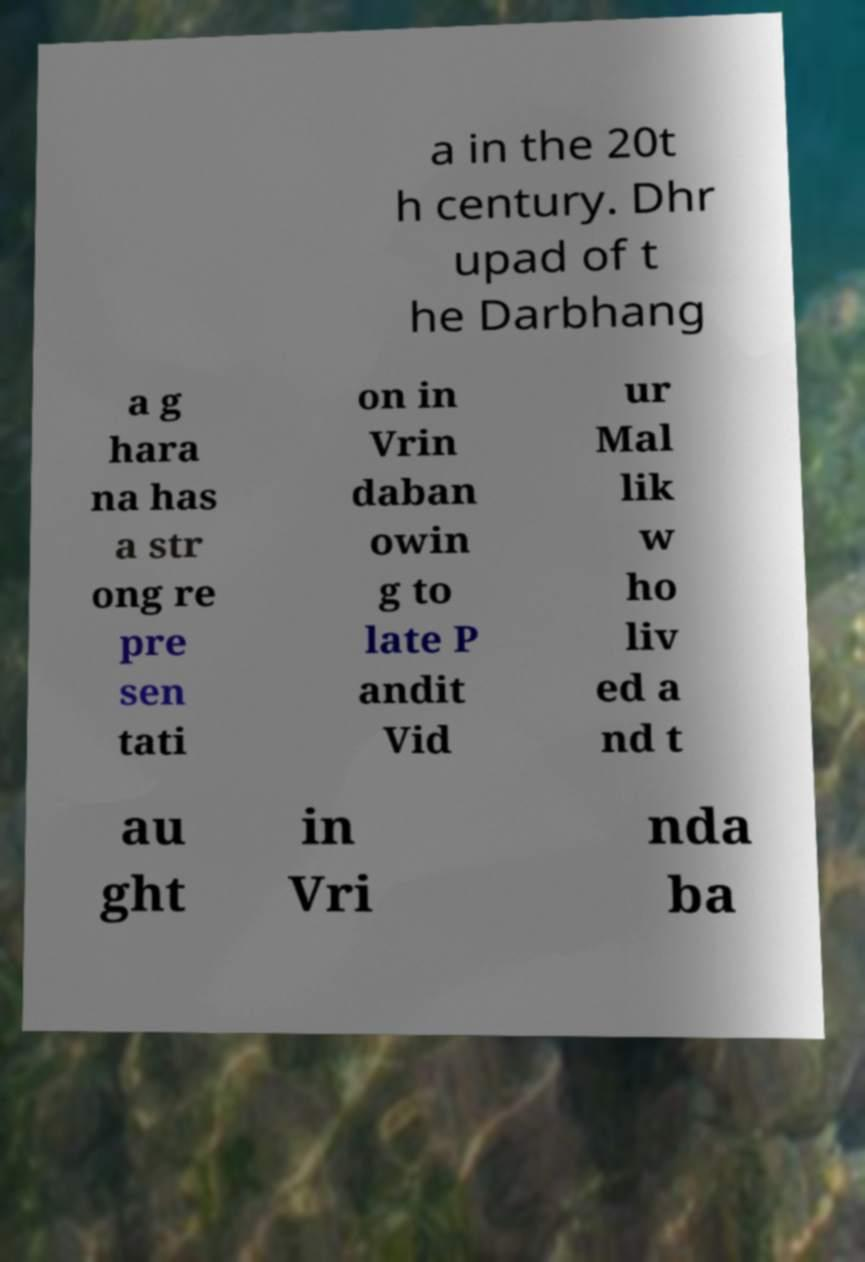For documentation purposes, I need the text within this image transcribed. Could you provide that? a in the 20t h century. Dhr upad of t he Darbhang a g hara na has a str ong re pre sen tati on in Vrin daban owin g to late P andit Vid ur Mal lik w ho liv ed a nd t au ght in Vri nda ba 